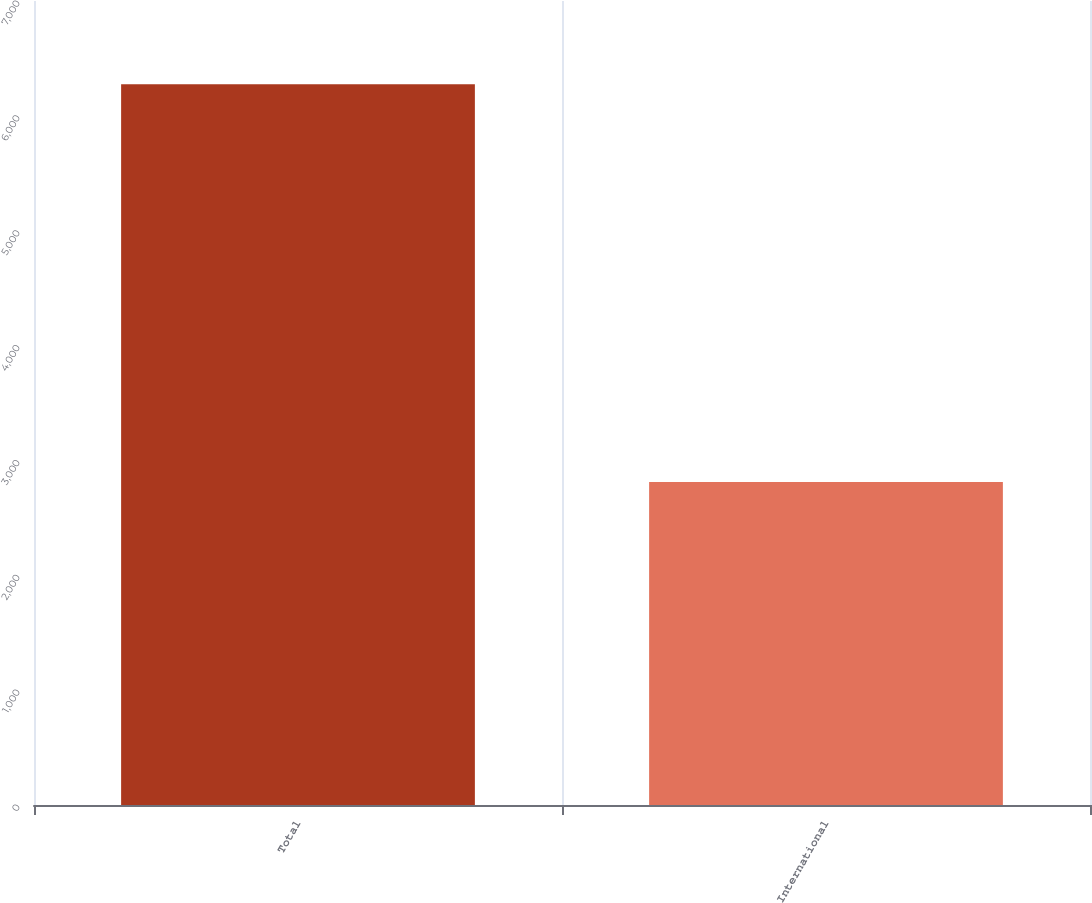Convert chart. <chart><loc_0><loc_0><loc_500><loc_500><bar_chart><fcel>Total<fcel>International<nl><fcel>6274.3<fcel>2813.2<nl></chart> 